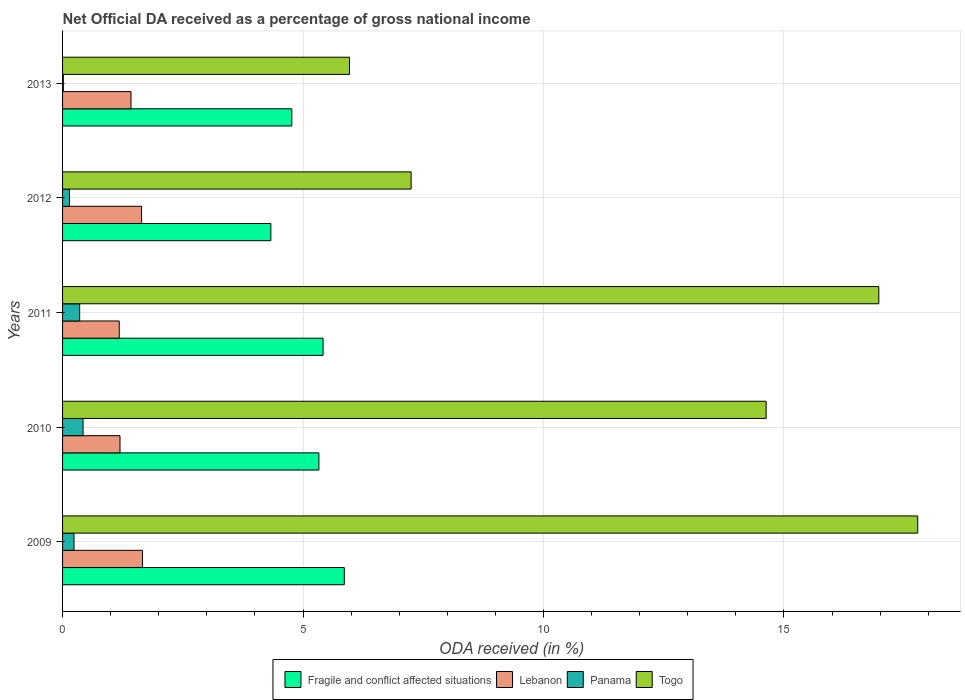Are the number of bars per tick equal to the number of legend labels?
Your answer should be very brief. Yes. How many bars are there on the 5th tick from the top?
Offer a very short reply. 4. What is the label of the 5th group of bars from the top?
Give a very brief answer. 2009. In how many cases, is the number of bars for a given year not equal to the number of legend labels?
Your response must be concise. 0. What is the net official DA received in Lebanon in 2011?
Your answer should be very brief. 1.18. Across all years, what is the maximum net official DA received in Fragile and conflict affected situations?
Ensure brevity in your answer.  5.86. Across all years, what is the minimum net official DA received in Fragile and conflict affected situations?
Offer a terse response. 4.33. In which year was the net official DA received in Panama maximum?
Offer a very short reply. 2010. In which year was the net official DA received in Lebanon minimum?
Keep it short and to the point. 2011. What is the total net official DA received in Lebanon in the graph?
Offer a terse response. 7.1. What is the difference between the net official DA received in Fragile and conflict affected situations in 2009 and that in 2010?
Offer a very short reply. 0.53. What is the difference between the net official DA received in Lebanon in 2011 and the net official DA received in Panama in 2013?
Your answer should be very brief. 1.16. What is the average net official DA received in Lebanon per year?
Your response must be concise. 1.42. In the year 2013, what is the difference between the net official DA received in Togo and net official DA received in Fragile and conflict affected situations?
Give a very brief answer. 1.2. What is the ratio of the net official DA received in Panama in 2009 to that in 2013?
Your response must be concise. 14.68. Is the net official DA received in Panama in 2010 less than that in 2011?
Keep it short and to the point. No. What is the difference between the highest and the second highest net official DA received in Panama?
Provide a succinct answer. 0.07. What is the difference between the highest and the lowest net official DA received in Fragile and conflict affected situations?
Provide a succinct answer. 1.53. Is the sum of the net official DA received in Togo in 2010 and 2012 greater than the maximum net official DA received in Panama across all years?
Ensure brevity in your answer.  Yes. Is it the case that in every year, the sum of the net official DA received in Panama and net official DA received in Togo is greater than the sum of net official DA received in Lebanon and net official DA received in Fragile and conflict affected situations?
Keep it short and to the point. No. What does the 4th bar from the top in 2009 represents?
Offer a very short reply. Fragile and conflict affected situations. What does the 3rd bar from the bottom in 2013 represents?
Offer a terse response. Panama. How many bars are there?
Make the answer very short. 20. What is the difference between two consecutive major ticks on the X-axis?
Your answer should be compact. 5. Are the values on the major ticks of X-axis written in scientific E-notation?
Make the answer very short. No. Does the graph contain any zero values?
Provide a succinct answer. No. How many legend labels are there?
Your answer should be compact. 4. How are the legend labels stacked?
Ensure brevity in your answer.  Horizontal. What is the title of the graph?
Your answer should be very brief. Net Official DA received as a percentage of gross national income. Does "Senegal" appear as one of the legend labels in the graph?
Provide a short and direct response. No. What is the label or title of the X-axis?
Keep it short and to the point. ODA received (in %). What is the ODA received (in %) of Fragile and conflict affected situations in 2009?
Offer a terse response. 5.86. What is the ODA received (in %) in Lebanon in 2009?
Give a very brief answer. 1.66. What is the ODA received (in %) of Panama in 2009?
Offer a terse response. 0.24. What is the ODA received (in %) in Togo in 2009?
Keep it short and to the point. 17.78. What is the ODA received (in %) in Fragile and conflict affected situations in 2010?
Provide a succinct answer. 5.33. What is the ODA received (in %) of Lebanon in 2010?
Offer a terse response. 1.19. What is the ODA received (in %) in Panama in 2010?
Offer a terse response. 0.43. What is the ODA received (in %) in Togo in 2010?
Provide a short and direct response. 14.63. What is the ODA received (in %) of Fragile and conflict affected situations in 2011?
Offer a very short reply. 5.42. What is the ODA received (in %) in Lebanon in 2011?
Provide a short and direct response. 1.18. What is the ODA received (in %) in Panama in 2011?
Offer a very short reply. 0.36. What is the ODA received (in %) in Togo in 2011?
Your answer should be compact. 16.97. What is the ODA received (in %) in Fragile and conflict affected situations in 2012?
Provide a succinct answer. 4.33. What is the ODA received (in %) in Lebanon in 2012?
Your answer should be compact. 1.64. What is the ODA received (in %) of Panama in 2012?
Your answer should be compact. 0.14. What is the ODA received (in %) in Togo in 2012?
Give a very brief answer. 7.25. What is the ODA received (in %) of Fragile and conflict affected situations in 2013?
Give a very brief answer. 4.77. What is the ODA received (in %) of Lebanon in 2013?
Your answer should be very brief. 1.42. What is the ODA received (in %) in Panama in 2013?
Ensure brevity in your answer.  0.02. What is the ODA received (in %) in Togo in 2013?
Make the answer very short. 5.97. Across all years, what is the maximum ODA received (in %) in Fragile and conflict affected situations?
Ensure brevity in your answer.  5.86. Across all years, what is the maximum ODA received (in %) of Lebanon?
Keep it short and to the point. 1.66. Across all years, what is the maximum ODA received (in %) in Panama?
Give a very brief answer. 0.43. Across all years, what is the maximum ODA received (in %) in Togo?
Offer a very short reply. 17.78. Across all years, what is the minimum ODA received (in %) in Fragile and conflict affected situations?
Ensure brevity in your answer.  4.33. Across all years, what is the minimum ODA received (in %) of Lebanon?
Ensure brevity in your answer.  1.18. Across all years, what is the minimum ODA received (in %) in Panama?
Keep it short and to the point. 0.02. Across all years, what is the minimum ODA received (in %) of Togo?
Provide a short and direct response. 5.97. What is the total ODA received (in %) of Fragile and conflict affected situations in the graph?
Keep it short and to the point. 25.7. What is the total ODA received (in %) of Lebanon in the graph?
Offer a very short reply. 7.1. What is the total ODA received (in %) of Panama in the graph?
Keep it short and to the point. 1.18. What is the total ODA received (in %) in Togo in the graph?
Keep it short and to the point. 62.6. What is the difference between the ODA received (in %) in Fragile and conflict affected situations in 2009 and that in 2010?
Give a very brief answer. 0.53. What is the difference between the ODA received (in %) of Lebanon in 2009 and that in 2010?
Your answer should be compact. 0.47. What is the difference between the ODA received (in %) of Panama in 2009 and that in 2010?
Provide a succinct answer. -0.19. What is the difference between the ODA received (in %) in Togo in 2009 and that in 2010?
Provide a short and direct response. 3.15. What is the difference between the ODA received (in %) in Fragile and conflict affected situations in 2009 and that in 2011?
Provide a short and direct response. 0.44. What is the difference between the ODA received (in %) of Lebanon in 2009 and that in 2011?
Your response must be concise. 0.48. What is the difference between the ODA received (in %) of Panama in 2009 and that in 2011?
Offer a very short reply. -0.12. What is the difference between the ODA received (in %) in Togo in 2009 and that in 2011?
Provide a short and direct response. 0.81. What is the difference between the ODA received (in %) of Fragile and conflict affected situations in 2009 and that in 2012?
Your answer should be very brief. 1.53. What is the difference between the ODA received (in %) of Lebanon in 2009 and that in 2012?
Keep it short and to the point. 0.02. What is the difference between the ODA received (in %) of Panama in 2009 and that in 2012?
Offer a very short reply. 0.09. What is the difference between the ODA received (in %) of Togo in 2009 and that in 2012?
Make the answer very short. 10.53. What is the difference between the ODA received (in %) of Fragile and conflict affected situations in 2009 and that in 2013?
Your response must be concise. 1.09. What is the difference between the ODA received (in %) in Lebanon in 2009 and that in 2013?
Offer a very short reply. 0.24. What is the difference between the ODA received (in %) in Panama in 2009 and that in 2013?
Provide a succinct answer. 0.22. What is the difference between the ODA received (in %) in Togo in 2009 and that in 2013?
Offer a terse response. 11.82. What is the difference between the ODA received (in %) of Fragile and conflict affected situations in 2010 and that in 2011?
Offer a very short reply. -0.09. What is the difference between the ODA received (in %) in Lebanon in 2010 and that in 2011?
Offer a very short reply. 0.02. What is the difference between the ODA received (in %) in Panama in 2010 and that in 2011?
Ensure brevity in your answer.  0.07. What is the difference between the ODA received (in %) in Togo in 2010 and that in 2011?
Ensure brevity in your answer.  -2.34. What is the difference between the ODA received (in %) of Fragile and conflict affected situations in 2010 and that in 2012?
Keep it short and to the point. 1. What is the difference between the ODA received (in %) in Lebanon in 2010 and that in 2012?
Offer a very short reply. -0.45. What is the difference between the ODA received (in %) in Panama in 2010 and that in 2012?
Provide a succinct answer. 0.28. What is the difference between the ODA received (in %) in Togo in 2010 and that in 2012?
Provide a short and direct response. 7.38. What is the difference between the ODA received (in %) of Fragile and conflict affected situations in 2010 and that in 2013?
Provide a short and direct response. 0.56. What is the difference between the ODA received (in %) in Lebanon in 2010 and that in 2013?
Keep it short and to the point. -0.23. What is the difference between the ODA received (in %) of Panama in 2010 and that in 2013?
Your answer should be very brief. 0.41. What is the difference between the ODA received (in %) in Togo in 2010 and that in 2013?
Your answer should be compact. 8.66. What is the difference between the ODA received (in %) of Fragile and conflict affected situations in 2011 and that in 2012?
Make the answer very short. 1.09. What is the difference between the ODA received (in %) in Lebanon in 2011 and that in 2012?
Keep it short and to the point. -0.46. What is the difference between the ODA received (in %) of Panama in 2011 and that in 2012?
Keep it short and to the point. 0.21. What is the difference between the ODA received (in %) in Togo in 2011 and that in 2012?
Give a very brief answer. 9.73. What is the difference between the ODA received (in %) of Fragile and conflict affected situations in 2011 and that in 2013?
Ensure brevity in your answer.  0.65. What is the difference between the ODA received (in %) in Lebanon in 2011 and that in 2013?
Make the answer very short. -0.24. What is the difference between the ODA received (in %) in Panama in 2011 and that in 2013?
Ensure brevity in your answer.  0.34. What is the difference between the ODA received (in %) in Togo in 2011 and that in 2013?
Provide a short and direct response. 11.01. What is the difference between the ODA received (in %) in Fragile and conflict affected situations in 2012 and that in 2013?
Offer a very short reply. -0.44. What is the difference between the ODA received (in %) of Lebanon in 2012 and that in 2013?
Offer a terse response. 0.22. What is the difference between the ODA received (in %) in Panama in 2012 and that in 2013?
Make the answer very short. 0.13. What is the difference between the ODA received (in %) of Togo in 2012 and that in 2013?
Provide a succinct answer. 1.28. What is the difference between the ODA received (in %) of Fragile and conflict affected situations in 2009 and the ODA received (in %) of Lebanon in 2010?
Your answer should be very brief. 4.66. What is the difference between the ODA received (in %) in Fragile and conflict affected situations in 2009 and the ODA received (in %) in Panama in 2010?
Ensure brevity in your answer.  5.43. What is the difference between the ODA received (in %) of Fragile and conflict affected situations in 2009 and the ODA received (in %) of Togo in 2010?
Ensure brevity in your answer.  -8.77. What is the difference between the ODA received (in %) in Lebanon in 2009 and the ODA received (in %) in Panama in 2010?
Ensure brevity in your answer.  1.24. What is the difference between the ODA received (in %) of Lebanon in 2009 and the ODA received (in %) of Togo in 2010?
Your answer should be very brief. -12.97. What is the difference between the ODA received (in %) in Panama in 2009 and the ODA received (in %) in Togo in 2010?
Keep it short and to the point. -14.39. What is the difference between the ODA received (in %) of Fragile and conflict affected situations in 2009 and the ODA received (in %) of Lebanon in 2011?
Give a very brief answer. 4.68. What is the difference between the ODA received (in %) in Fragile and conflict affected situations in 2009 and the ODA received (in %) in Panama in 2011?
Provide a succinct answer. 5.5. What is the difference between the ODA received (in %) in Fragile and conflict affected situations in 2009 and the ODA received (in %) in Togo in 2011?
Keep it short and to the point. -11.11. What is the difference between the ODA received (in %) in Lebanon in 2009 and the ODA received (in %) in Panama in 2011?
Offer a terse response. 1.31. What is the difference between the ODA received (in %) in Lebanon in 2009 and the ODA received (in %) in Togo in 2011?
Your answer should be compact. -15.31. What is the difference between the ODA received (in %) in Panama in 2009 and the ODA received (in %) in Togo in 2011?
Offer a very short reply. -16.74. What is the difference between the ODA received (in %) of Fragile and conflict affected situations in 2009 and the ODA received (in %) of Lebanon in 2012?
Provide a succinct answer. 4.22. What is the difference between the ODA received (in %) in Fragile and conflict affected situations in 2009 and the ODA received (in %) in Panama in 2012?
Your response must be concise. 5.71. What is the difference between the ODA received (in %) of Fragile and conflict affected situations in 2009 and the ODA received (in %) of Togo in 2012?
Your answer should be compact. -1.39. What is the difference between the ODA received (in %) of Lebanon in 2009 and the ODA received (in %) of Panama in 2012?
Provide a succinct answer. 1.52. What is the difference between the ODA received (in %) of Lebanon in 2009 and the ODA received (in %) of Togo in 2012?
Your answer should be very brief. -5.59. What is the difference between the ODA received (in %) in Panama in 2009 and the ODA received (in %) in Togo in 2012?
Your answer should be compact. -7.01. What is the difference between the ODA received (in %) of Fragile and conflict affected situations in 2009 and the ODA received (in %) of Lebanon in 2013?
Ensure brevity in your answer.  4.44. What is the difference between the ODA received (in %) in Fragile and conflict affected situations in 2009 and the ODA received (in %) in Panama in 2013?
Provide a succinct answer. 5.84. What is the difference between the ODA received (in %) in Fragile and conflict affected situations in 2009 and the ODA received (in %) in Togo in 2013?
Offer a very short reply. -0.11. What is the difference between the ODA received (in %) of Lebanon in 2009 and the ODA received (in %) of Panama in 2013?
Your answer should be very brief. 1.65. What is the difference between the ODA received (in %) of Lebanon in 2009 and the ODA received (in %) of Togo in 2013?
Provide a short and direct response. -4.3. What is the difference between the ODA received (in %) of Panama in 2009 and the ODA received (in %) of Togo in 2013?
Offer a very short reply. -5.73. What is the difference between the ODA received (in %) in Fragile and conflict affected situations in 2010 and the ODA received (in %) in Lebanon in 2011?
Keep it short and to the point. 4.15. What is the difference between the ODA received (in %) of Fragile and conflict affected situations in 2010 and the ODA received (in %) of Panama in 2011?
Provide a succinct answer. 4.97. What is the difference between the ODA received (in %) of Fragile and conflict affected situations in 2010 and the ODA received (in %) of Togo in 2011?
Your answer should be compact. -11.64. What is the difference between the ODA received (in %) in Lebanon in 2010 and the ODA received (in %) in Panama in 2011?
Make the answer very short. 0.84. What is the difference between the ODA received (in %) in Lebanon in 2010 and the ODA received (in %) in Togo in 2011?
Give a very brief answer. -15.78. What is the difference between the ODA received (in %) of Panama in 2010 and the ODA received (in %) of Togo in 2011?
Provide a short and direct response. -16.55. What is the difference between the ODA received (in %) in Fragile and conflict affected situations in 2010 and the ODA received (in %) in Lebanon in 2012?
Make the answer very short. 3.69. What is the difference between the ODA received (in %) in Fragile and conflict affected situations in 2010 and the ODA received (in %) in Panama in 2012?
Your answer should be compact. 5.19. What is the difference between the ODA received (in %) in Fragile and conflict affected situations in 2010 and the ODA received (in %) in Togo in 2012?
Provide a short and direct response. -1.92. What is the difference between the ODA received (in %) in Lebanon in 2010 and the ODA received (in %) in Panama in 2012?
Keep it short and to the point. 1.05. What is the difference between the ODA received (in %) of Lebanon in 2010 and the ODA received (in %) of Togo in 2012?
Provide a succinct answer. -6.05. What is the difference between the ODA received (in %) in Panama in 2010 and the ODA received (in %) in Togo in 2012?
Your answer should be very brief. -6.82. What is the difference between the ODA received (in %) in Fragile and conflict affected situations in 2010 and the ODA received (in %) in Lebanon in 2013?
Your answer should be compact. 3.91. What is the difference between the ODA received (in %) of Fragile and conflict affected situations in 2010 and the ODA received (in %) of Panama in 2013?
Your response must be concise. 5.31. What is the difference between the ODA received (in %) of Fragile and conflict affected situations in 2010 and the ODA received (in %) of Togo in 2013?
Make the answer very short. -0.64. What is the difference between the ODA received (in %) of Lebanon in 2010 and the ODA received (in %) of Panama in 2013?
Ensure brevity in your answer.  1.18. What is the difference between the ODA received (in %) of Lebanon in 2010 and the ODA received (in %) of Togo in 2013?
Provide a succinct answer. -4.77. What is the difference between the ODA received (in %) of Panama in 2010 and the ODA received (in %) of Togo in 2013?
Provide a short and direct response. -5.54. What is the difference between the ODA received (in %) in Fragile and conflict affected situations in 2011 and the ODA received (in %) in Lebanon in 2012?
Offer a very short reply. 3.77. What is the difference between the ODA received (in %) of Fragile and conflict affected situations in 2011 and the ODA received (in %) of Panama in 2012?
Offer a very short reply. 5.27. What is the difference between the ODA received (in %) in Fragile and conflict affected situations in 2011 and the ODA received (in %) in Togo in 2012?
Your answer should be very brief. -1.83. What is the difference between the ODA received (in %) in Lebanon in 2011 and the ODA received (in %) in Panama in 2012?
Your answer should be compact. 1.03. What is the difference between the ODA received (in %) of Lebanon in 2011 and the ODA received (in %) of Togo in 2012?
Offer a terse response. -6.07. What is the difference between the ODA received (in %) in Panama in 2011 and the ODA received (in %) in Togo in 2012?
Your answer should be compact. -6.89. What is the difference between the ODA received (in %) in Fragile and conflict affected situations in 2011 and the ODA received (in %) in Lebanon in 2013?
Ensure brevity in your answer.  3.99. What is the difference between the ODA received (in %) of Fragile and conflict affected situations in 2011 and the ODA received (in %) of Panama in 2013?
Ensure brevity in your answer.  5.4. What is the difference between the ODA received (in %) of Fragile and conflict affected situations in 2011 and the ODA received (in %) of Togo in 2013?
Your answer should be very brief. -0.55. What is the difference between the ODA received (in %) of Lebanon in 2011 and the ODA received (in %) of Panama in 2013?
Your answer should be very brief. 1.16. What is the difference between the ODA received (in %) of Lebanon in 2011 and the ODA received (in %) of Togo in 2013?
Your response must be concise. -4.79. What is the difference between the ODA received (in %) of Panama in 2011 and the ODA received (in %) of Togo in 2013?
Provide a succinct answer. -5.61. What is the difference between the ODA received (in %) in Fragile and conflict affected situations in 2012 and the ODA received (in %) in Lebanon in 2013?
Provide a short and direct response. 2.91. What is the difference between the ODA received (in %) in Fragile and conflict affected situations in 2012 and the ODA received (in %) in Panama in 2013?
Offer a very short reply. 4.31. What is the difference between the ODA received (in %) of Fragile and conflict affected situations in 2012 and the ODA received (in %) of Togo in 2013?
Give a very brief answer. -1.64. What is the difference between the ODA received (in %) in Lebanon in 2012 and the ODA received (in %) in Panama in 2013?
Your answer should be very brief. 1.63. What is the difference between the ODA received (in %) of Lebanon in 2012 and the ODA received (in %) of Togo in 2013?
Provide a succinct answer. -4.32. What is the difference between the ODA received (in %) in Panama in 2012 and the ODA received (in %) in Togo in 2013?
Ensure brevity in your answer.  -5.82. What is the average ODA received (in %) in Fragile and conflict affected situations per year?
Your response must be concise. 5.14. What is the average ODA received (in %) in Lebanon per year?
Your response must be concise. 1.42. What is the average ODA received (in %) of Panama per year?
Keep it short and to the point. 0.24. What is the average ODA received (in %) of Togo per year?
Your answer should be compact. 12.52. In the year 2009, what is the difference between the ODA received (in %) in Fragile and conflict affected situations and ODA received (in %) in Lebanon?
Keep it short and to the point. 4.2. In the year 2009, what is the difference between the ODA received (in %) of Fragile and conflict affected situations and ODA received (in %) of Panama?
Ensure brevity in your answer.  5.62. In the year 2009, what is the difference between the ODA received (in %) in Fragile and conflict affected situations and ODA received (in %) in Togo?
Provide a short and direct response. -11.92. In the year 2009, what is the difference between the ODA received (in %) of Lebanon and ODA received (in %) of Panama?
Offer a very short reply. 1.42. In the year 2009, what is the difference between the ODA received (in %) of Lebanon and ODA received (in %) of Togo?
Keep it short and to the point. -16.12. In the year 2009, what is the difference between the ODA received (in %) of Panama and ODA received (in %) of Togo?
Provide a short and direct response. -17.54. In the year 2010, what is the difference between the ODA received (in %) of Fragile and conflict affected situations and ODA received (in %) of Lebanon?
Offer a terse response. 4.14. In the year 2010, what is the difference between the ODA received (in %) in Fragile and conflict affected situations and ODA received (in %) in Panama?
Keep it short and to the point. 4.9. In the year 2010, what is the difference between the ODA received (in %) in Fragile and conflict affected situations and ODA received (in %) in Togo?
Offer a terse response. -9.3. In the year 2010, what is the difference between the ODA received (in %) of Lebanon and ODA received (in %) of Panama?
Your answer should be compact. 0.77. In the year 2010, what is the difference between the ODA received (in %) of Lebanon and ODA received (in %) of Togo?
Ensure brevity in your answer.  -13.44. In the year 2010, what is the difference between the ODA received (in %) in Panama and ODA received (in %) in Togo?
Offer a very short reply. -14.2. In the year 2011, what is the difference between the ODA received (in %) of Fragile and conflict affected situations and ODA received (in %) of Lebanon?
Provide a succinct answer. 4.24. In the year 2011, what is the difference between the ODA received (in %) of Fragile and conflict affected situations and ODA received (in %) of Panama?
Ensure brevity in your answer.  5.06. In the year 2011, what is the difference between the ODA received (in %) of Fragile and conflict affected situations and ODA received (in %) of Togo?
Keep it short and to the point. -11.56. In the year 2011, what is the difference between the ODA received (in %) in Lebanon and ODA received (in %) in Panama?
Your response must be concise. 0.82. In the year 2011, what is the difference between the ODA received (in %) of Lebanon and ODA received (in %) of Togo?
Your answer should be compact. -15.8. In the year 2011, what is the difference between the ODA received (in %) of Panama and ODA received (in %) of Togo?
Ensure brevity in your answer.  -16.62. In the year 2012, what is the difference between the ODA received (in %) in Fragile and conflict affected situations and ODA received (in %) in Lebanon?
Provide a short and direct response. 2.69. In the year 2012, what is the difference between the ODA received (in %) of Fragile and conflict affected situations and ODA received (in %) of Panama?
Ensure brevity in your answer.  4.19. In the year 2012, what is the difference between the ODA received (in %) in Fragile and conflict affected situations and ODA received (in %) in Togo?
Your answer should be compact. -2.92. In the year 2012, what is the difference between the ODA received (in %) in Lebanon and ODA received (in %) in Panama?
Provide a succinct answer. 1.5. In the year 2012, what is the difference between the ODA received (in %) in Lebanon and ODA received (in %) in Togo?
Give a very brief answer. -5.61. In the year 2012, what is the difference between the ODA received (in %) in Panama and ODA received (in %) in Togo?
Offer a very short reply. -7.1. In the year 2013, what is the difference between the ODA received (in %) of Fragile and conflict affected situations and ODA received (in %) of Lebanon?
Your answer should be very brief. 3.34. In the year 2013, what is the difference between the ODA received (in %) in Fragile and conflict affected situations and ODA received (in %) in Panama?
Offer a terse response. 4.75. In the year 2013, what is the difference between the ODA received (in %) of Fragile and conflict affected situations and ODA received (in %) of Togo?
Provide a short and direct response. -1.2. In the year 2013, what is the difference between the ODA received (in %) of Lebanon and ODA received (in %) of Panama?
Provide a short and direct response. 1.41. In the year 2013, what is the difference between the ODA received (in %) in Lebanon and ODA received (in %) in Togo?
Keep it short and to the point. -4.54. In the year 2013, what is the difference between the ODA received (in %) in Panama and ODA received (in %) in Togo?
Offer a terse response. -5.95. What is the ratio of the ODA received (in %) in Fragile and conflict affected situations in 2009 to that in 2010?
Give a very brief answer. 1.1. What is the ratio of the ODA received (in %) of Lebanon in 2009 to that in 2010?
Your response must be concise. 1.39. What is the ratio of the ODA received (in %) of Panama in 2009 to that in 2010?
Make the answer very short. 0.56. What is the ratio of the ODA received (in %) in Togo in 2009 to that in 2010?
Your answer should be very brief. 1.22. What is the ratio of the ODA received (in %) of Fragile and conflict affected situations in 2009 to that in 2011?
Provide a short and direct response. 1.08. What is the ratio of the ODA received (in %) of Lebanon in 2009 to that in 2011?
Make the answer very short. 1.41. What is the ratio of the ODA received (in %) in Panama in 2009 to that in 2011?
Provide a short and direct response. 0.67. What is the ratio of the ODA received (in %) in Togo in 2009 to that in 2011?
Your answer should be very brief. 1.05. What is the ratio of the ODA received (in %) in Fragile and conflict affected situations in 2009 to that in 2012?
Provide a succinct answer. 1.35. What is the ratio of the ODA received (in %) in Lebanon in 2009 to that in 2012?
Offer a terse response. 1.01. What is the ratio of the ODA received (in %) of Panama in 2009 to that in 2012?
Provide a succinct answer. 1.65. What is the ratio of the ODA received (in %) of Togo in 2009 to that in 2012?
Make the answer very short. 2.45. What is the ratio of the ODA received (in %) of Fragile and conflict affected situations in 2009 to that in 2013?
Provide a short and direct response. 1.23. What is the ratio of the ODA received (in %) in Lebanon in 2009 to that in 2013?
Offer a terse response. 1.17. What is the ratio of the ODA received (in %) in Panama in 2009 to that in 2013?
Provide a short and direct response. 14.68. What is the ratio of the ODA received (in %) of Togo in 2009 to that in 2013?
Offer a very short reply. 2.98. What is the ratio of the ODA received (in %) of Fragile and conflict affected situations in 2010 to that in 2011?
Ensure brevity in your answer.  0.98. What is the ratio of the ODA received (in %) of Lebanon in 2010 to that in 2011?
Your answer should be very brief. 1.01. What is the ratio of the ODA received (in %) in Panama in 2010 to that in 2011?
Offer a terse response. 1.2. What is the ratio of the ODA received (in %) of Togo in 2010 to that in 2011?
Your answer should be compact. 0.86. What is the ratio of the ODA received (in %) of Fragile and conflict affected situations in 2010 to that in 2012?
Give a very brief answer. 1.23. What is the ratio of the ODA received (in %) of Lebanon in 2010 to that in 2012?
Offer a very short reply. 0.73. What is the ratio of the ODA received (in %) of Panama in 2010 to that in 2012?
Provide a succinct answer. 2.96. What is the ratio of the ODA received (in %) of Togo in 2010 to that in 2012?
Your answer should be compact. 2.02. What is the ratio of the ODA received (in %) in Fragile and conflict affected situations in 2010 to that in 2013?
Your answer should be compact. 1.12. What is the ratio of the ODA received (in %) of Lebanon in 2010 to that in 2013?
Give a very brief answer. 0.84. What is the ratio of the ODA received (in %) in Panama in 2010 to that in 2013?
Offer a terse response. 26.3. What is the ratio of the ODA received (in %) in Togo in 2010 to that in 2013?
Offer a very short reply. 2.45. What is the ratio of the ODA received (in %) in Fragile and conflict affected situations in 2011 to that in 2012?
Keep it short and to the point. 1.25. What is the ratio of the ODA received (in %) in Lebanon in 2011 to that in 2012?
Make the answer very short. 0.72. What is the ratio of the ODA received (in %) of Panama in 2011 to that in 2012?
Your response must be concise. 2.47. What is the ratio of the ODA received (in %) of Togo in 2011 to that in 2012?
Provide a succinct answer. 2.34. What is the ratio of the ODA received (in %) in Fragile and conflict affected situations in 2011 to that in 2013?
Provide a succinct answer. 1.14. What is the ratio of the ODA received (in %) in Lebanon in 2011 to that in 2013?
Make the answer very short. 0.83. What is the ratio of the ODA received (in %) in Panama in 2011 to that in 2013?
Make the answer very short. 21.95. What is the ratio of the ODA received (in %) of Togo in 2011 to that in 2013?
Ensure brevity in your answer.  2.84. What is the ratio of the ODA received (in %) in Fragile and conflict affected situations in 2012 to that in 2013?
Your answer should be very brief. 0.91. What is the ratio of the ODA received (in %) in Lebanon in 2012 to that in 2013?
Your response must be concise. 1.15. What is the ratio of the ODA received (in %) in Panama in 2012 to that in 2013?
Give a very brief answer. 8.9. What is the ratio of the ODA received (in %) of Togo in 2012 to that in 2013?
Your answer should be compact. 1.21. What is the difference between the highest and the second highest ODA received (in %) of Fragile and conflict affected situations?
Your response must be concise. 0.44. What is the difference between the highest and the second highest ODA received (in %) of Lebanon?
Provide a short and direct response. 0.02. What is the difference between the highest and the second highest ODA received (in %) of Panama?
Give a very brief answer. 0.07. What is the difference between the highest and the second highest ODA received (in %) in Togo?
Offer a terse response. 0.81. What is the difference between the highest and the lowest ODA received (in %) of Fragile and conflict affected situations?
Your response must be concise. 1.53. What is the difference between the highest and the lowest ODA received (in %) of Lebanon?
Provide a succinct answer. 0.48. What is the difference between the highest and the lowest ODA received (in %) in Panama?
Provide a succinct answer. 0.41. What is the difference between the highest and the lowest ODA received (in %) of Togo?
Offer a terse response. 11.82. 